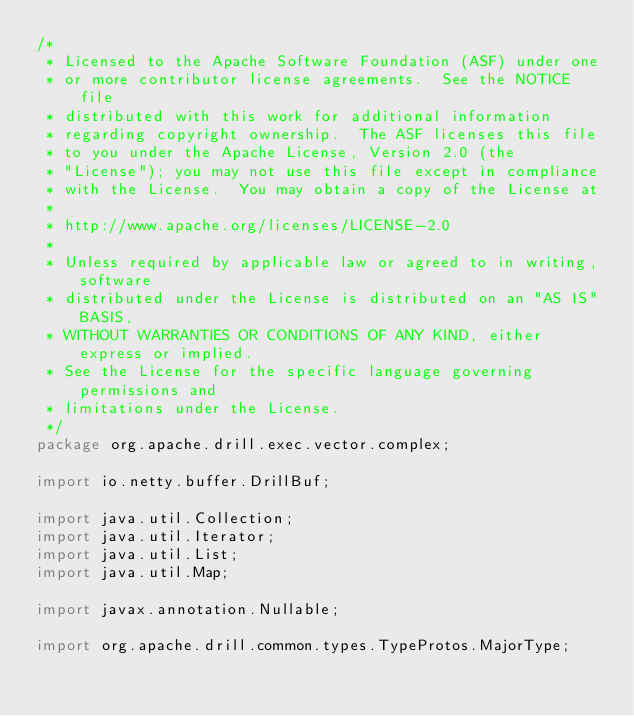Convert code to text. <code><loc_0><loc_0><loc_500><loc_500><_Java_>/*
 * Licensed to the Apache Software Foundation (ASF) under one
 * or more contributor license agreements.  See the NOTICE file
 * distributed with this work for additional information
 * regarding copyright ownership.  The ASF licenses this file
 * to you under the Apache License, Version 2.0 (the
 * "License"); you may not use this file except in compliance
 * with the License.  You may obtain a copy of the License at
 *
 * http://www.apache.org/licenses/LICENSE-2.0
 *
 * Unless required by applicable law or agreed to in writing, software
 * distributed under the License is distributed on an "AS IS" BASIS,
 * WITHOUT WARRANTIES OR CONDITIONS OF ANY KIND, either express or implied.
 * See the License for the specific language governing permissions and
 * limitations under the License.
 */
package org.apache.drill.exec.vector.complex;

import io.netty.buffer.DrillBuf;

import java.util.Collection;
import java.util.Iterator;
import java.util.List;
import java.util.Map;

import javax.annotation.Nullable;

import org.apache.drill.common.types.TypeProtos.MajorType;</code> 